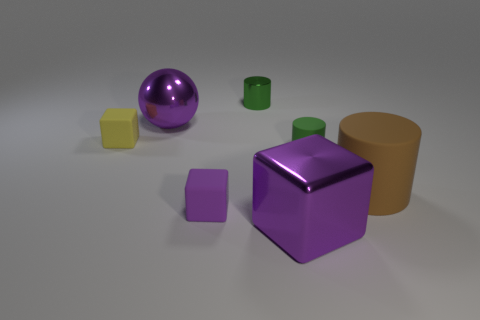What number of tiny green things are behind the large thing that is to the left of the big purple shiny cube right of the tiny purple object?
Your answer should be compact. 1. Does the small block in front of the green matte cylinder have the same color as the metallic thing in front of the big matte cylinder?
Make the answer very short. Yes. Is there any other thing that has the same color as the big block?
Offer a very short reply. Yes. There is a small rubber cube right of the large metal thing that is left of the purple metal block; what is its color?
Your answer should be very brief. Purple. Are there any brown shiny cubes?
Ensure brevity in your answer.  No. What color is the object that is behind the large brown matte thing and in front of the small yellow block?
Your answer should be very brief. Green. Does the object right of the green matte thing have the same size as the metallic thing behind the large shiny ball?
Offer a terse response. No. How many other things are the same size as the metal block?
Provide a short and direct response. 2. There is a cylinder to the left of the tiny green matte cylinder; what number of metallic cubes are behind it?
Your answer should be compact. 0. Are there fewer green metal cylinders that are to the right of the purple rubber thing than cyan rubber cubes?
Make the answer very short. No. 